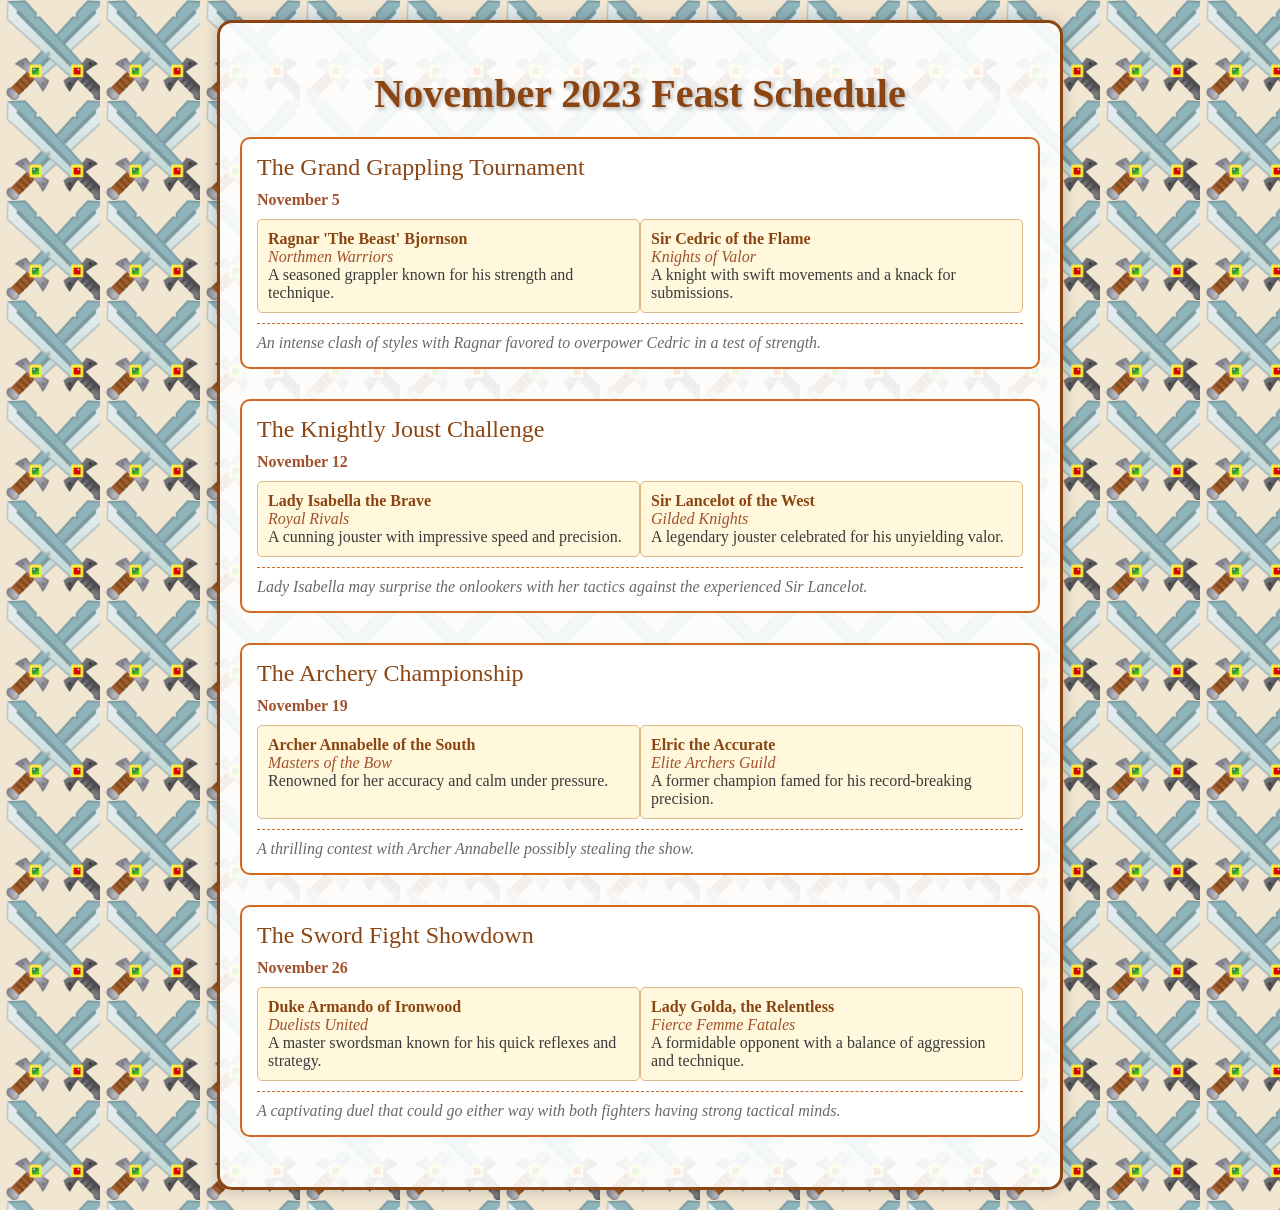What is the date of The Grand Grappling Tournament? The date is explicitly mentioned as November 5 in the event description.
Answer: November 5 Who is favored to win The Grand Grappling Tournament? According to the expected outcome, Ragnar is favored to overpower Cedric in this event.
Answer: Ragnar 'The Beast' Bjornson Which event features Lady Isabella the Brave? The event that includes her is clearly titled the Knightly Joust Challenge.
Answer: The Knightly Joust Challenge Who are the participants in The Archery Championship? The document lists Archer Annabelle and Elric the Accurate as participants in this championship.
Answer: Archer Annabelle of the South and Elric the Accurate What is expected from Lady Isabella in the Knightly Joust Challenge? The expected outcome suggests that Lady Isabella may surprise the onlookers with her tactics.
Answer: Surprise the onlookers How many events are scheduled in November 2023? The schedule provides details on four distinct events taking place throughout the month.
Answer: Four events Which participant has a team called Masters of the Bow? The document identifies Archer Annabelle as the participant associated with this team.
Answer: Archer Annabelle of the South What unique fighting style is attributed to Duke Armando of Ironwood? He is described as a master swordsman known for his quick reflexes and strategy, indicating his fighting style.
Answer: Quick reflexes and strategy 